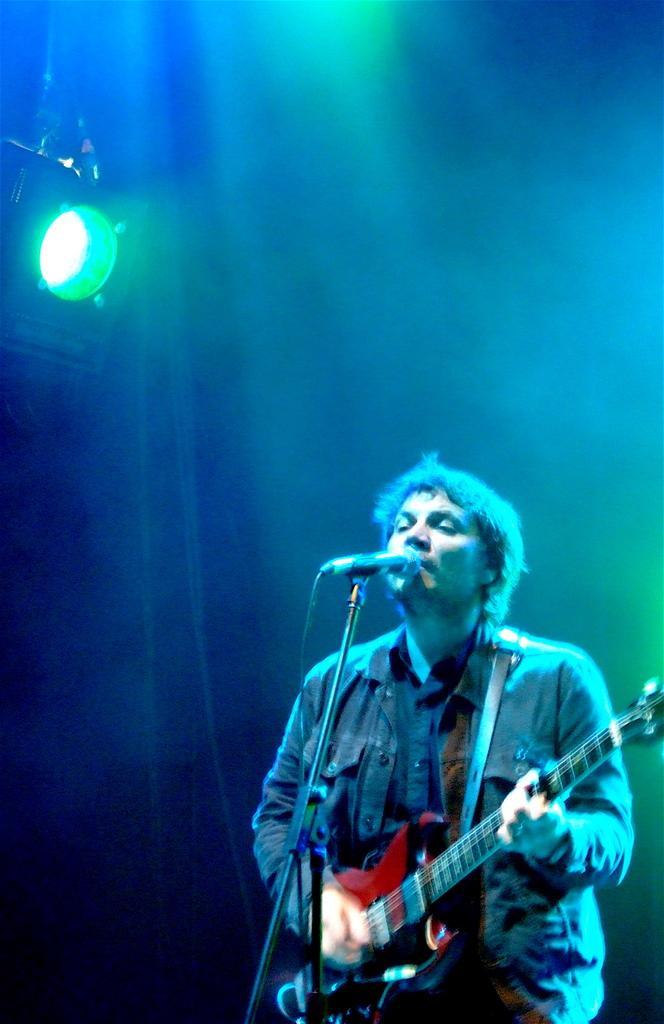In one or two sentences, can you explain what this image depicts? Here in this picture we can see a person standing in front of microphone. He is singing and playing guitar. And this is the light which is in green color. 